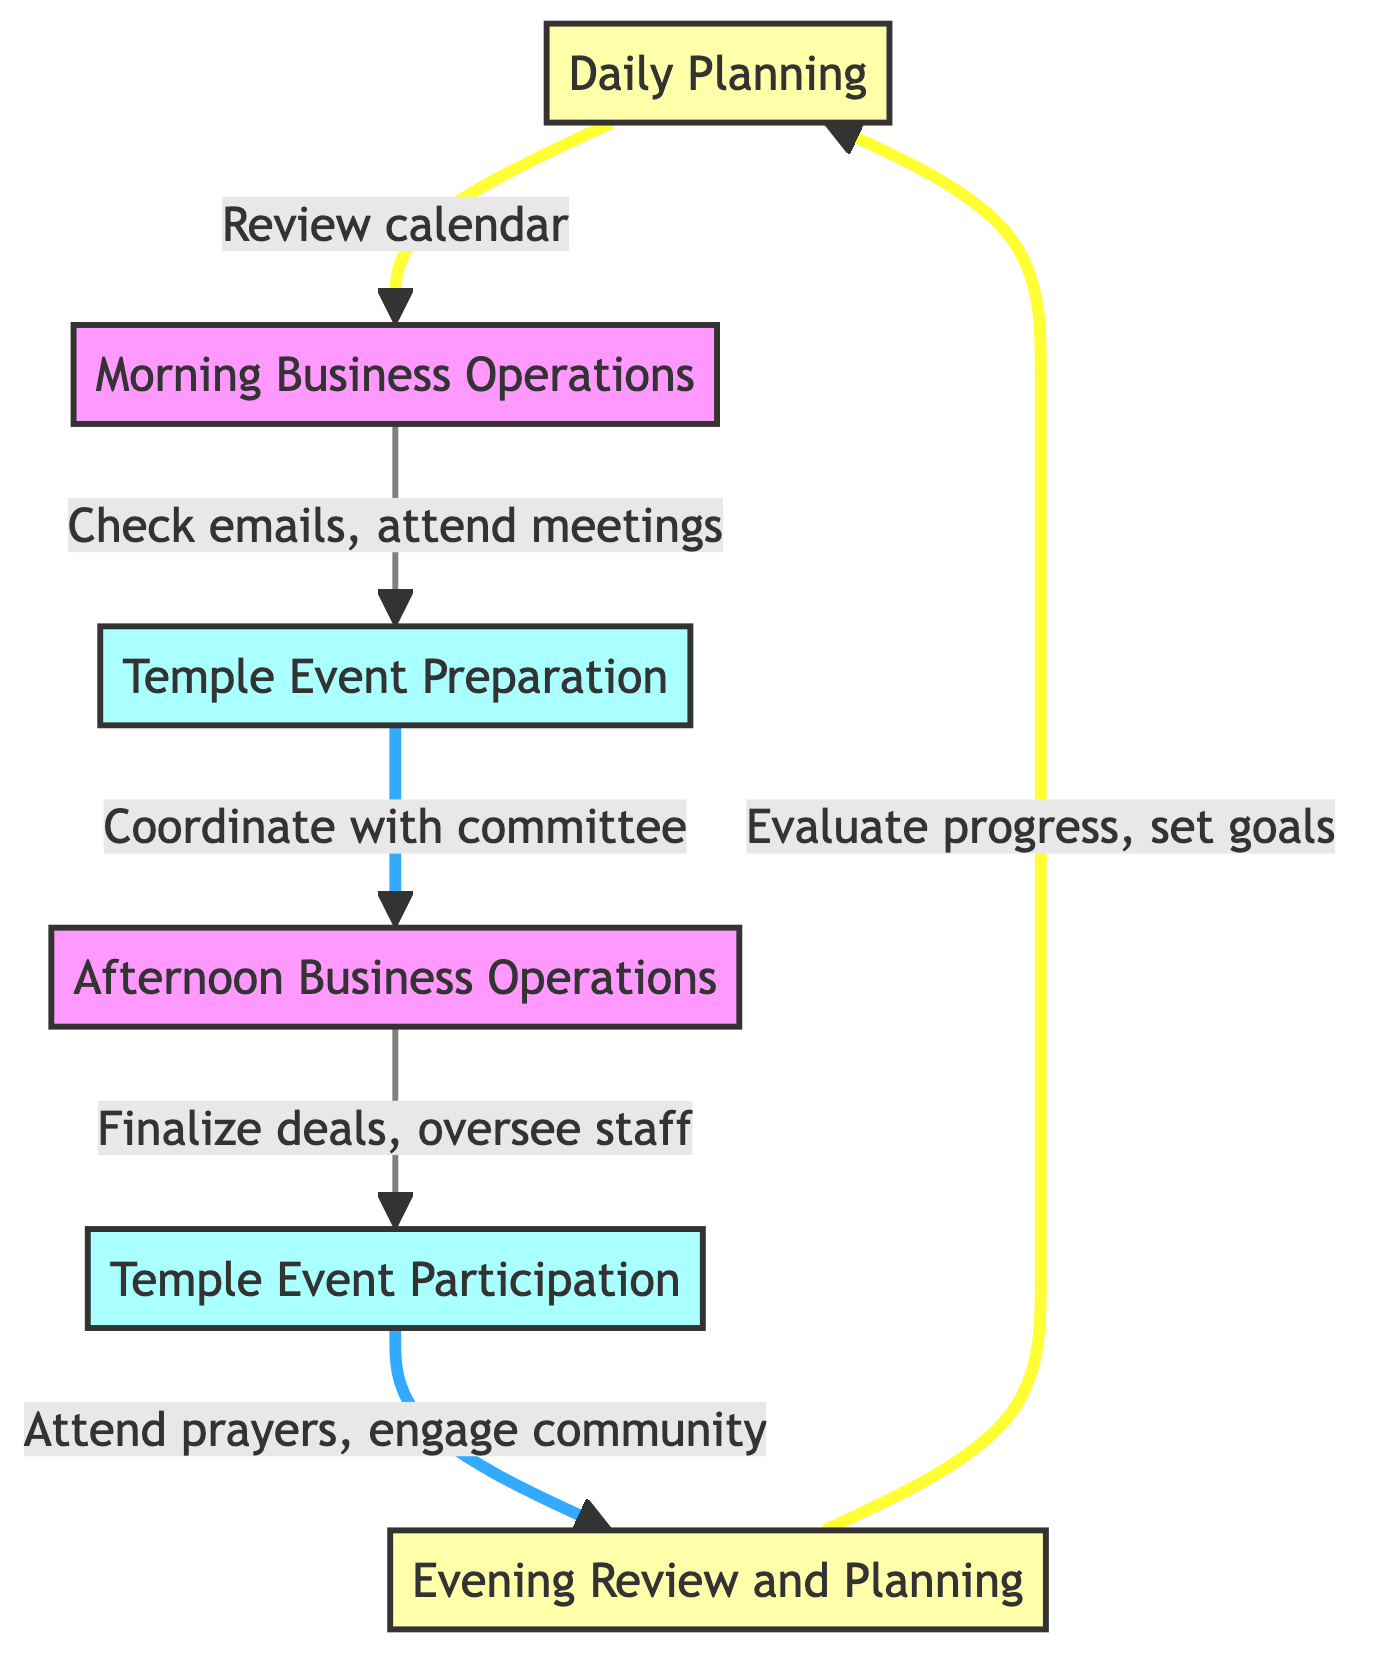What is the first step in the diagram? The first step in the diagram is "Daily Planning," as it is the initial node that starts the flow of operations.
Answer: Daily Planning How many steps are there in total in the flowchart? The diagram displays a total of six steps that describe the daily business operations and temple event commitments.
Answer: Six What output is generated after the "Temple Event Preparation"? The output generated after the "Temple Event Preparation" step is "Prepared event materials," which indicates what is accomplished in this step.
Answer: Prepared event materials Which step directly follows "Afternoon Business Operations"? The step that directly follows "Afternoon Business Operations" is "Temple Event Participation," as this is the next action in the flow of operations.
Answer: Temple Event Participation What action is associated with "Evening Review and Planning"? The action associated with "Evening Review and Planning" is "Evaluate progress, set next day goals," summarizing what is done to review the day's events.
Answer: Evaluate progress, set next day goals In which steps are temple event activities involved? Temple event activities are involved in "Temple Event Preparation" and "Temple Event Participation," showing the focus on temple events at these two parts of the flow.
Answer: Temple Event Preparation, Temple Event Participation What tool is used in the "Morning Business Operations"? In the "Morning Business Operations," the tools used include "Email client" and "Meeting software," which facilitate communication and meetings during this time.
Answer: Email client, Meeting software What is the main purpose of the "Daily Planning" step? The main purpose of the "Daily Planning" step is to outline business tasks and temple activities for the day, providing a clear structure for the day's operations.
Answer: Outline business tasks and temple activities How does the process return to "Daily Planning"? The process returns to "Daily Planning" after "Evening Review and Planning," indicating a cyclical nature where each day's review informs the next day’s planning.
Answer: After "Evening Review and Planning" 